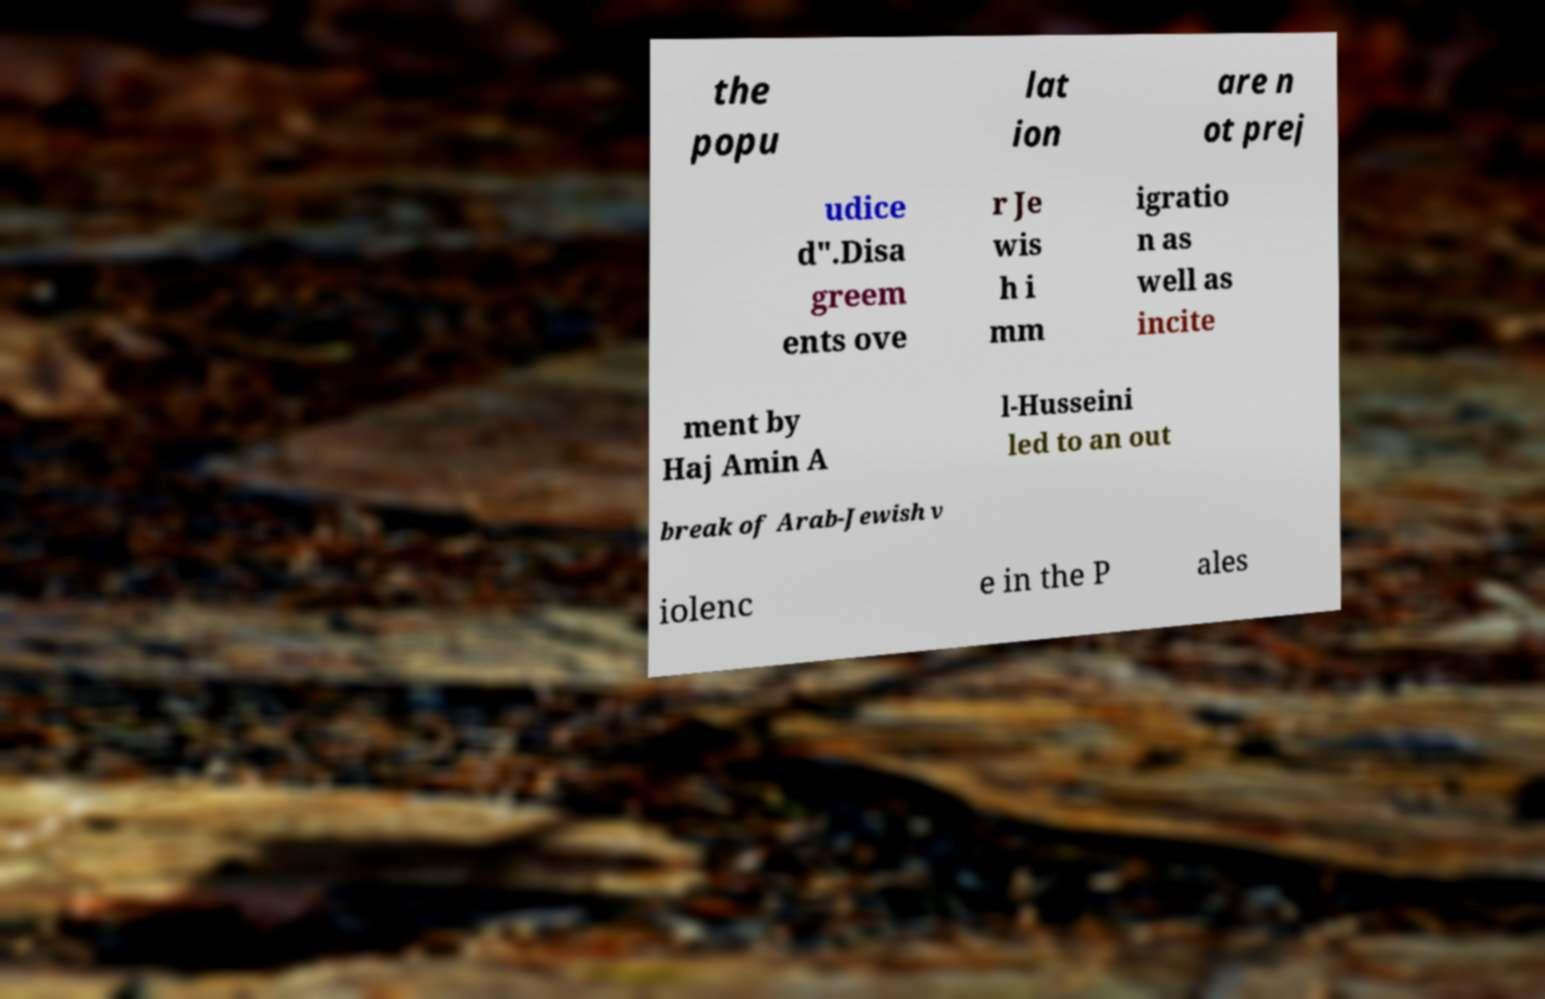There's text embedded in this image that I need extracted. Can you transcribe it verbatim? the popu lat ion are n ot prej udice d".Disa greem ents ove r Je wis h i mm igratio n as well as incite ment by Haj Amin A l-Husseini led to an out break of Arab-Jewish v iolenc e in the P ales 